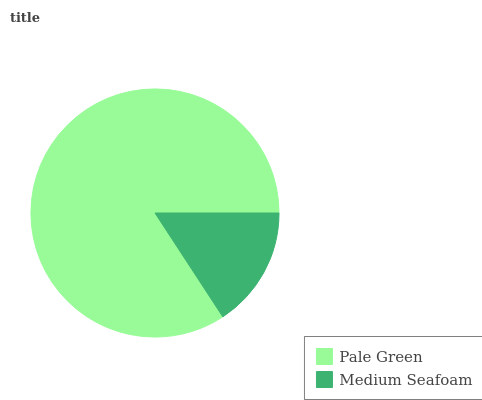Is Medium Seafoam the minimum?
Answer yes or no. Yes. Is Pale Green the maximum?
Answer yes or no. Yes. Is Medium Seafoam the maximum?
Answer yes or no. No. Is Pale Green greater than Medium Seafoam?
Answer yes or no. Yes. Is Medium Seafoam less than Pale Green?
Answer yes or no. Yes. Is Medium Seafoam greater than Pale Green?
Answer yes or no. No. Is Pale Green less than Medium Seafoam?
Answer yes or no. No. Is Pale Green the high median?
Answer yes or no. Yes. Is Medium Seafoam the low median?
Answer yes or no. Yes. Is Medium Seafoam the high median?
Answer yes or no. No. Is Pale Green the low median?
Answer yes or no. No. 